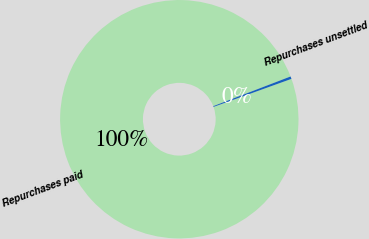Convert chart to OTSL. <chart><loc_0><loc_0><loc_500><loc_500><pie_chart><fcel>Repurchases paid<fcel>Repurchases unsettled<nl><fcel>99.66%<fcel>0.34%<nl></chart> 